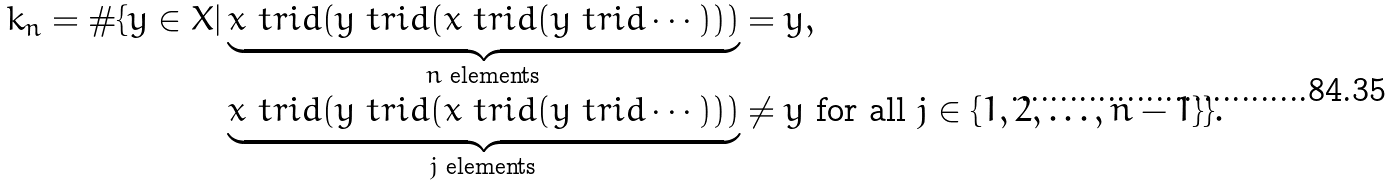<formula> <loc_0><loc_0><loc_500><loc_500>k _ { n } = \# \{ y \in X | & \underbrace { x \ t r i d ( y \ t r i d ( x \ t r i d ( y \ t r i d \cdots ) ) ) } _ { n \text { elements} } = y , \\ & \underbrace { x \ t r i d ( y \ t r i d ( x \ t r i d ( y \ t r i d \cdots ) ) ) } _ { j \text { elements} } \not = y \text { for all $j\in \{1,2,\dots ,n-1\}$} \} .</formula> 